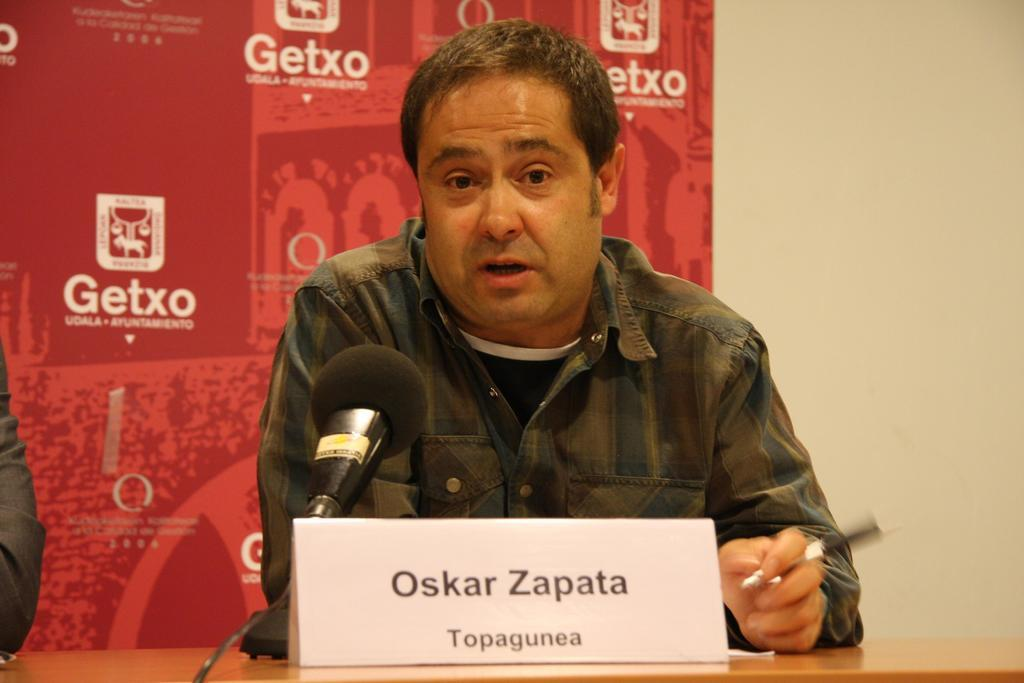What is the person holding in the image? The person is holding a pen. What is in front of the person? There is a table in front of the person. What is on the table? There is a name board and a mic on the table. What is behind the table? There is a wall in front of the person. What is in front of the wall? There is a red hoarding in front of the wall. What type of oatmeal is being served on the table in the image? There is no oatmeal present in the image; the table contains a name board and a mic. Is there a bear visible in the image? No, there is no bear present in the image. 